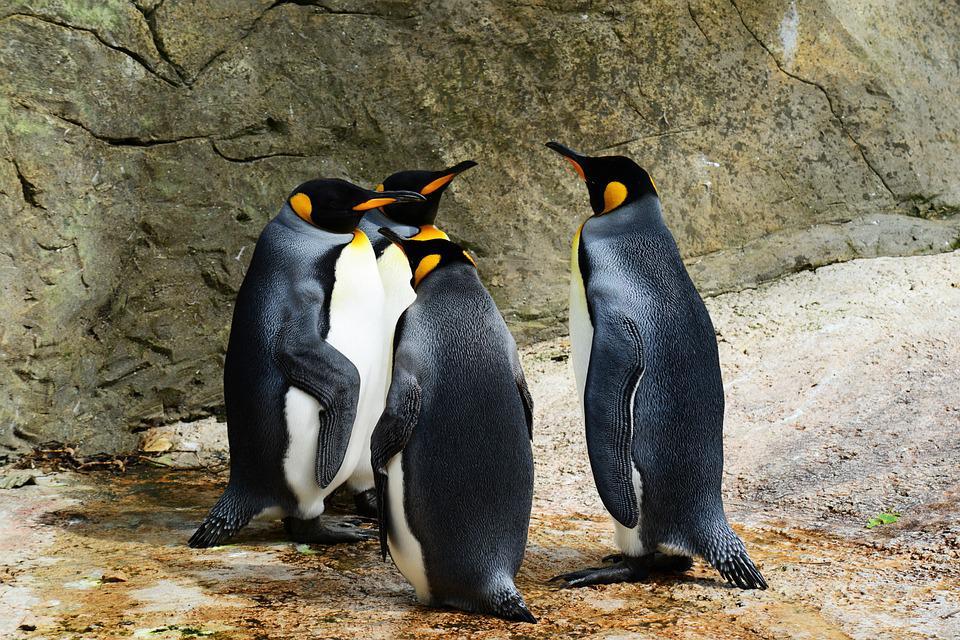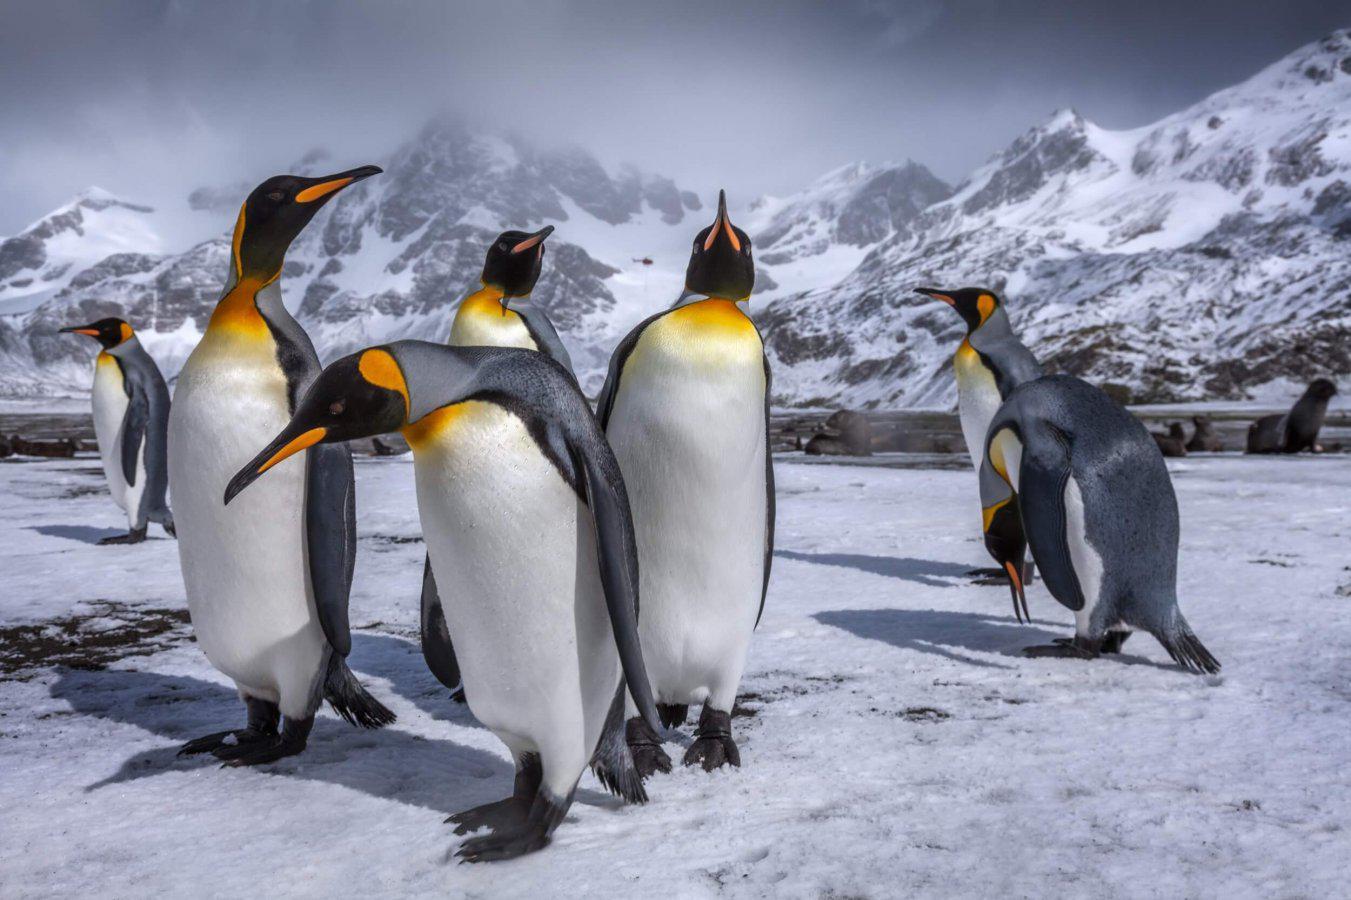The first image is the image on the left, the second image is the image on the right. Assess this claim about the two images: "There are no more than four penguins standing together in the image on the left.". Correct or not? Answer yes or no. Yes. The first image is the image on the left, the second image is the image on the right. Considering the images on both sides, is "Left image contains multiple penguins with backs turned to the camera." valid? Answer yes or no. Yes. 